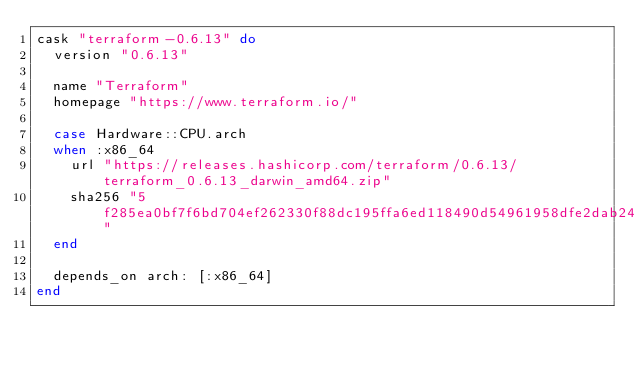Convert code to text. <code><loc_0><loc_0><loc_500><loc_500><_Ruby_>cask "terraform-0.6.13" do
  version "0.6.13"

  name "Terraform"
  homepage "https://www.terraform.io/"

  case Hardware::CPU.arch
  when :x86_64
    url "https://releases.hashicorp.com/terraform/0.6.13/terraform_0.6.13_darwin_amd64.zip"
    sha256 "5f285ea0bf7f6bd704ef262330f88dc195ffa6ed118490d54961958dfe2dab24"
  end

  depends_on arch: [:x86_64]
end
</code> 